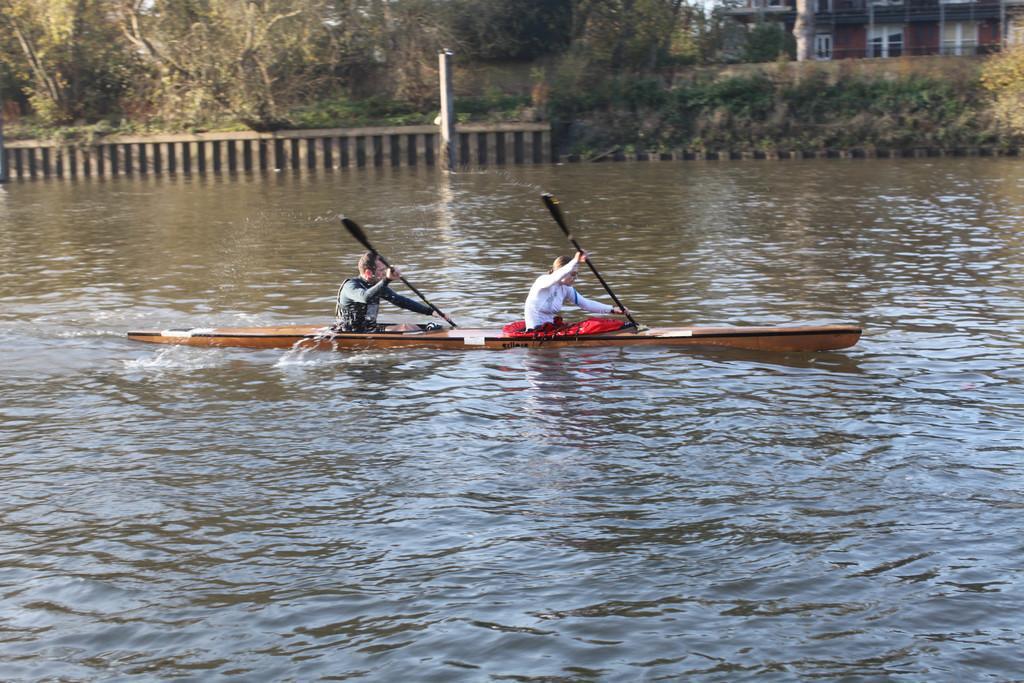In one or two sentences, can you explain what this image depicts? In this image, in the middle there is a boat on that there are two people, they are holding sticks, sitting. At the bottom there are waves, water. In the background there are trees, plants, grass, houses. 